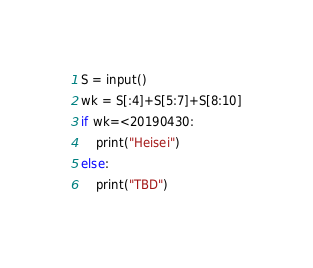<code> <loc_0><loc_0><loc_500><loc_500><_Python_>S = input()
wk = S[:4]+S[5:7]+S[8:10]
if wk=<20190430:
    print("Heisei")
else:
    print("TBD")</code> 